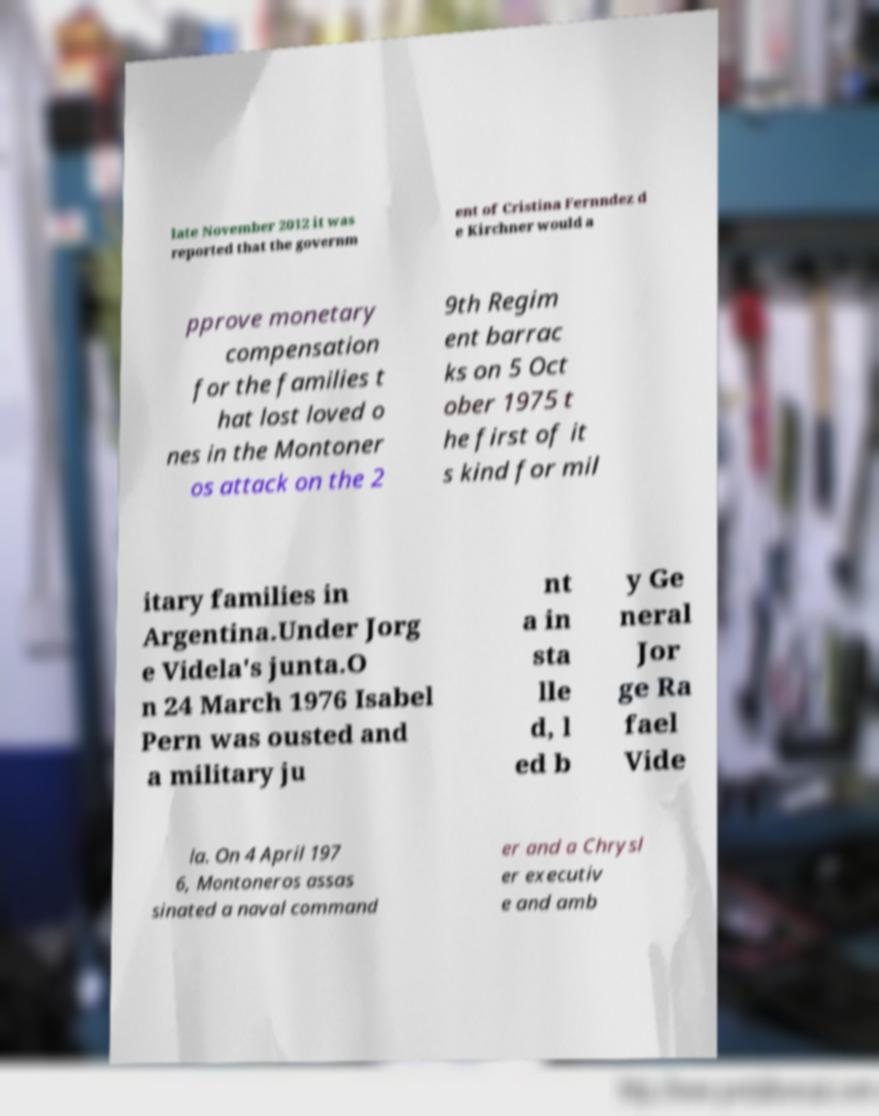Please identify and transcribe the text found in this image. late November 2012 it was reported that the governm ent of Cristina Fernndez d e Kirchner would a pprove monetary compensation for the families t hat lost loved o nes in the Montoner os attack on the 2 9th Regim ent barrac ks on 5 Oct ober 1975 t he first of it s kind for mil itary families in Argentina.Under Jorg e Videla's junta.O n 24 March 1976 Isabel Pern was ousted and a military ju nt a in sta lle d, l ed b y Ge neral Jor ge Ra fael Vide la. On 4 April 197 6, Montoneros assas sinated a naval command er and a Chrysl er executiv e and amb 